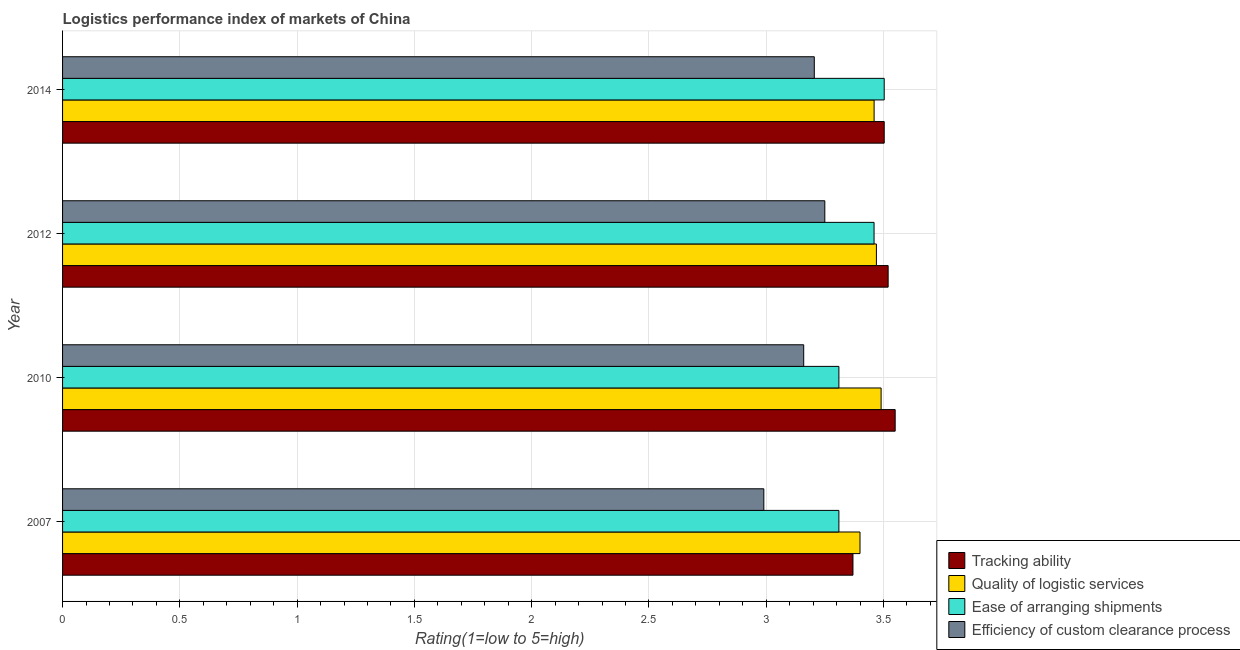How many groups of bars are there?
Your answer should be compact. 4. Are the number of bars on each tick of the Y-axis equal?
Your answer should be compact. Yes. How many bars are there on the 2nd tick from the top?
Ensure brevity in your answer.  4. How many bars are there on the 4th tick from the bottom?
Your answer should be very brief. 4. What is the label of the 1st group of bars from the top?
Offer a very short reply. 2014. What is the lpi rating of quality of logistic services in 2010?
Make the answer very short. 3.49. Across all years, what is the maximum lpi rating of ease of arranging shipments?
Ensure brevity in your answer.  3.5. Across all years, what is the minimum lpi rating of ease of arranging shipments?
Your response must be concise. 3.31. In which year was the lpi rating of efficiency of custom clearance process maximum?
Offer a terse response. 2012. In which year was the lpi rating of tracking ability minimum?
Your response must be concise. 2007. What is the total lpi rating of tracking ability in the graph?
Your answer should be very brief. 13.94. What is the difference between the lpi rating of efficiency of custom clearance process in 2007 and that in 2012?
Ensure brevity in your answer.  -0.26. What is the difference between the lpi rating of tracking ability in 2012 and the lpi rating of ease of arranging shipments in 2014?
Give a very brief answer. 0.02. What is the average lpi rating of efficiency of custom clearance process per year?
Offer a very short reply. 3.15. In the year 2007, what is the difference between the lpi rating of quality of logistic services and lpi rating of tracking ability?
Offer a very short reply. 0.03. In how many years, is the lpi rating of tracking ability greater than 2.4 ?
Provide a succinct answer. 4. Is the difference between the lpi rating of quality of logistic services in 2010 and 2014 greater than the difference between the lpi rating of efficiency of custom clearance process in 2010 and 2014?
Keep it short and to the point. Yes. What is the difference between the highest and the second highest lpi rating of efficiency of custom clearance process?
Your response must be concise. 0.04. What is the difference between the highest and the lowest lpi rating of efficiency of custom clearance process?
Ensure brevity in your answer.  0.26. In how many years, is the lpi rating of quality of logistic services greater than the average lpi rating of quality of logistic services taken over all years?
Provide a short and direct response. 3. Is the sum of the lpi rating of ease of arranging shipments in 2010 and 2014 greater than the maximum lpi rating of quality of logistic services across all years?
Offer a terse response. Yes. What does the 3rd bar from the top in 2010 represents?
Provide a short and direct response. Quality of logistic services. What does the 4th bar from the bottom in 2012 represents?
Provide a succinct answer. Efficiency of custom clearance process. Is it the case that in every year, the sum of the lpi rating of tracking ability and lpi rating of quality of logistic services is greater than the lpi rating of ease of arranging shipments?
Your answer should be very brief. Yes. How many bars are there?
Ensure brevity in your answer.  16. Are the values on the major ticks of X-axis written in scientific E-notation?
Provide a succinct answer. No. How are the legend labels stacked?
Offer a terse response. Vertical. What is the title of the graph?
Your answer should be compact. Logistics performance index of markets of China. What is the label or title of the X-axis?
Your answer should be compact. Rating(1=low to 5=high). What is the Rating(1=low to 5=high) in Tracking ability in 2007?
Offer a very short reply. 3.37. What is the Rating(1=low to 5=high) in Quality of logistic services in 2007?
Provide a succinct answer. 3.4. What is the Rating(1=low to 5=high) in Ease of arranging shipments in 2007?
Provide a short and direct response. 3.31. What is the Rating(1=low to 5=high) of Efficiency of custom clearance process in 2007?
Offer a very short reply. 2.99. What is the Rating(1=low to 5=high) in Tracking ability in 2010?
Give a very brief answer. 3.55. What is the Rating(1=low to 5=high) in Quality of logistic services in 2010?
Your answer should be very brief. 3.49. What is the Rating(1=low to 5=high) in Ease of arranging shipments in 2010?
Give a very brief answer. 3.31. What is the Rating(1=low to 5=high) in Efficiency of custom clearance process in 2010?
Keep it short and to the point. 3.16. What is the Rating(1=low to 5=high) in Tracking ability in 2012?
Make the answer very short. 3.52. What is the Rating(1=low to 5=high) of Quality of logistic services in 2012?
Your answer should be compact. 3.47. What is the Rating(1=low to 5=high) of Ease of arranging shipments in 2012?
Provide a short and direct response. 3.46. What is the Rating(1=low to 5=high) in Efficiency of custom clearance process in 2012?
Give a very brief answer. 3.25. What is the Rating(1=low to 5=high) of Tracking ability in 2014?
Provide a short and direct response. 3.5. What is the Rating(1=low to 5=high) in Quality of logistic services in 2014?
Keep it short and to the point. 3.46. What is the Rating(1=low to 5=high) of Ease of arranging shipments in 2014?
Make the answer very short. 3.5. What is the Rating(1=low to 5=high) in Efficiency of custom clearance process in 2014?
Provide a short and direct response. 3.21. Across all years, what is the maximum Rating(1=low to 5=high) in Tracking ability?
Make the answer very short. 3.55. Across all years, what is the maximum Rating(1=low to 5=high) in Quality of logistic services?
Offer a very short reply. 3.49. Across all years, what is the maximum Rating(1=low to 5=high) of Ease of arranging shipments?
Your answer should be very brief. 3.5. Across all years, what is the minimum Rating(1=low to 5=high) in Tracking ability?
Your answer should be very brief. 3.37. Across all years, what is the minimum Rating(1=low to 5=high) in Quality of logistic services?
Ensure brevity in your answer.  3.4. Across all years, what is the minimum Rating(1=low to 5=high) in Ease of arranging shipments?
Offer a very short reply. 3.31. Across all years, what is the minimum Rating(1=low to 5=high) of Efficiency of custom clearance process?
Make the answer very short. 2.99. What is the total Rating(1=low to 5=high) of Tracking ability in the graph?
Make the answer very short. 13.94. What is the total Rating(1=low to 5=high) in Quality of logistic services in the graph?
Make the answer very short. 13.82. What is the total Rating(1=low to 5=high) of Ease of arranging shipments in the graph?
Make the answer very short. 13.58. What is the total Rating(1=low to 5=high) of Efficiency of custom clearance process in the graph?
Give a very brief answer. 12.61. What is the difference between the Rating(1=low to 5=high) in Tracking ability in 2007 and that in 2010?
Offer a terse response. -0.18. What is the difference between the Rating(1=low to 5=high) of Quality of logistic services in 2007 and that in 2010?
Provide a short and direct response. -0.09. What is the difference between the Rating(1=low to 5=high) of Efficiency of custom clearance process in 2007 and that in 2010?
Keep it short and to the point. -0.17. What is the difference between the Rating(1=low to 5=high) in Tracking ability in 2007 and that in 2012?
Make the answer very short. -0.15. What is the difference between the Rating(1=low to 5=high) in Quality of logistic services in 2007 and that in 2012?
Your answer should be compact. -0.07. What is the difference between the Rating(1=low to 5=high) in Efficiency of custom clearance process in 2007 and that in 2012?
Provide a succinct answer. -0.26. What is the difference between the Rating(1=low to 5=high) in Tracking ability in 2007 and that in 2014?
Keep it short and to the point. -0.13. What is the difference between the Rating(1=low to 5=high) in Quality of logistic services in 2007 and that in 2014?
Keep it short and to the point. -0.06. What is the difference between the Rating(1=low to 5=high) in Ease of arranging shipments in 2007 and that in 2014?
Your answer should be compact. -0.19. What is the difference between the Rating(1=low to 5=high) of Efficiency of custom clearance process in 2007 and that in 2014?
Your response must be concise. -0.22. What is the difference between the Rating(1=low to 5=high) of Quality of logistic services in 2010 and that in 2012?
Provide a succinct answer. 0.02. What is the difference between the Rating(1=low to 5=high) of Efficiency of custom clearance process in 2010 and that in 2012?
Ensure brevity in your answer.  -0.09. What is the difference between the Rating(1=low to 5=high) of Tracking ability in 2010 and that in 2014?
Give a very brief answer. 0.05. What is the difference between the Rating(1=low to 5=high) of Quality of logistic services in 2010 and that in 2014?
Offer a terse response. 0.03. What is the difference between the Rating(1=low to 5=high) in Ease of arranging shipments in 2010 and that in 2014?
Make the answer very short. -0.19. What is the difference between the Rating(1=low to 5=high) of Efficiency of custom clearance process in 2010 and that in 2014?
Provide a short and direct response. -0.05. What is the difference between the Rating(1=low to 5=high) in Tracking ability in 2012 and that in 2014?
Make the answer very short. 0.02. What is the difference between the Rating(1=low to 5=high) of Quality of logistic services in 2012 and that in 2014?
Offer a very short reply. 0.01. What is the difference between the Rating(1=low to 5=high) of Ease of arranging shipments in 2012 and that in 2014?
Ensure brevity in your answer.  -0.04. What is the difference between the Rating(1=low to 5=high) in Efficiency of custom clearance process in 2012 and that in 2014?
Provide a short and direct response. 0.04. What is the difference between the Rating(1=low to 5=high) of Tracking ability in 2007 and the Rating(1=low to 5=high) of Quality of logistic services in 2010?
Provide a short and direct response. -0.12. What is the difference between the Rating(1=low to 5=high) of Tracking ability in 2007 and the Rating(1=low to 5=high) of Efficiency of custom clearance process in 2010?
Your answer should be very brief. 0.21. What is the difference between the Rating(1=low to 5=high) of Quality of logistic services in 2007 and the Rating(1=low to 5=high) of Ease of arranging shipments in 2010?
Keep it short and to the point. 0.09. What is the difference between the Rating(1=low to 5=high) in Quality of logistic services in 2007 and the Rating(1=low to 5=high) in Efficiency of custom clearance process in 2010?
Keep it short and to the point. 0.24. What is the difference between the Rating(1=low to 5=high) of Tracking ability in 2007 and the Rating(1=low to 5=high) of Quality of logistic services in 2012?
Offer a terse response. -0.1. What is the difference between the Rating(1=low to 5=high) of Tracking ability in 2007 and the Rating(1=low to 5=high) of Ease of arranging shipments in 2012?
Offer a very short reply. -0.09. What is the difference between the Rating(1=low to 5=high) in Tracking ability in 2007 and the Rating(1=low to 5=high) in Efficiency of custom clearance process in 2012?
Provide a short and direct response. 0.12. What is the difference between the Rating(1=low to 5=high) of Quality of logistic services in 2007 and the Rating(1=low to 5=high) of Ease of arranging shipments in 2012?
Provide a short and direct response. -0.06. What is the difference between the Rating(1=low to 5=high) in Quality of logistic services in 2007 and the Rating(1=low to 5=high) in Efficiency of custom clearance process in 2012?
Provide a short and direct response. 0.15. What is the difference between the Rating(1=low to 5=high) in Ease of arranging shipments in 2007 and the Rating(1=low to 5=high) in Efficiency of custom clearance process in 2012?
Keep it short and to the point. 0.06. What is the difference between the Rating(1=low to 5=high) in Tracking ability in 2007 and the Rating(1=low to 5=high) in Quality of logistic services in 2014?
Offer a very short reply. -0.09. What is the difference between the Rating(1=low to 5=high) of Tracking ability in 2007 and the Rating(1=low to 5=high) of Ease of arranging shipments in 2014?
Give a very brief answer. -0.13. What is the difference between the Rating(1=low to 5=high) in Tracking ability in 2007 and the Rating(1=low to 5=high) in Efficiency of custom clearance process in 2014?
Offer a very short reply. 0.16. What is the difference between the Rating(1=low to 5=high) in Quality of logistic services in 2007 and the Rating(1=low to 5=high) in Ease of arranging shipments in 2014?
Your answer should be very brief. -0.1. What is the difference between the Rating(1=low to 5=high) in Quality of logistic services in 2007 and the Rating(1=low to 5=high) in Efficiency of custom clearance process in 2014?
Provide a short and direct response. 0.19. What is the difference between the Rating(1=low to 5=high) of Ease of arranging shipments in 2007 and the Rating(1=low to 5=high) of Efficiency of custom clearance process in 2014?
Ensure brevity in your answer.  0.1. What is the difference between the Rating(1=low to 5=high) in Tracking ability in 2010 and the Rating(1=low to 5=high) in Ease of arranging shipments in 2012?
Make the answer very short. 0.09. What is the difference between the Rating(1=low to 5=high) of Tracking ability in 2010 and the Rating(1=low to 5=high) of Efficiency of custom clearance process in 2012?
Give a very brief answer. 0.3. What is the difference between the Rating(1=low to 5=high) in Quality of logistic services in 2010 and the Rating(1=low to 5=high) in Ease of arranging shipments in 2012?
Provide a succinct answer. 0.03. What is the difference between the Rating(1=low to 5=high) in Quality of logistic services in 2010 and the Rating(1=low to 5=high) in Efficiency of custom clearance process in 2012?
Keep it short and to the point. 0.24. What is the difference between the Rating(1=low to 5=high) of Ease of arranging shipments in 2010 and the Rating(1=low to 5=high) of Efficiency of custom clearance process in 2012?
Your response must be concise. 0.06. What is the difference between the Rating(1=low to 5=high) of Tracking ability in 2010 and the Rating(1=low to 5=high) of Quality of logistic services in 2014?
Your answer should be very brief. 0.09. What is the difference between the Rating(1=low to 5=high) in Tracking ability in 2010 and the Rating(1=low to 5=high) in Ease of arranging shipments in 2014?
Your response must be concise. 0.05. What is the difference between the Rating(1=low to 5=high) in Tracking ability in 2010 and the Rating(1=low to 5=high) in Efficiency of custom clearance process in 2014?
Your answer should be very brief. 0.34. What is the difference between the Rating(1=low to 5=high) of Quality of logistic services in 2010 and the Rating(1=low to 5=high) of Ease of arranging shipments in 2014?
Give a very brief answer. -0.01. What is the difference between the Rating(1=low to 5=high) in Quality of logistic services in 2010 and the Rating(1=low to 5=high) in Efficiency of custom clearance process in 2014?
Provide a short and direct response. 0.28. What is the difference between the Rating(1=low to 5=high) of Ease of arranging shipments in 2010 and the Rating(1=low to 5=high) of Efficiency of custom clearance process in 2014?
Your answer should be very brief. 0.1. What is the difference between the Rating(1=low to 5=high) in Tracking ability in 2012 and the Rating(1=low to 5=high) in Quality of logistic services in 2014?
Your answer should be very brief. 0.06. What is the difference between the Rating(1=low to 5=high) in Tracking ability in 2012 and the Rating(1=low to 5=high) in Ease of arranging shipments in 2014?
Your answer should be compact. 0.02. What is the difference between the Rating(1=low to 5=high) of Tracking ability in 2012 and the Rating(1=low to 5=high) of Efficiency of custom clearance process in 2014?
Give a very brief answer. 0.31. What is the difference between the Rating(1=low to 5=high) of Quality of logistic services in 2012 and the Rating(1=low to 5=high) of Ease of arranging shipments in 2014?
Offer a very short reply. -0.03. What is the difference between the Rating(1=low to 5=high) of Quality of logistic services in 2012 and the Rating(1=low to 5=high) of Efficiency of custom clearance process in 2014?
Keep it short and to the point. 0.26. What is the difference between the Rating(1=low to 5=high) of Ease of arranging shipments in 2012 and the Rating(1=low to 5=high) of Efficiency of custom clearance process in 2014?
Your response must be concise. 0.25. What is the average Rating(1=low to 5=high) in Tracking ability per year?
Provide a succinct answer. 3.49. What is the average Rating(1=low to 5=high) in Quality of logistic services per year?
Your answer should be very brief. 3.46. What is the average Rating(1=low to 5=high) of Ease of arranging shipments per year?
Your answer should be compact. 3.4. What is the average Rating(1=low to 5=high) in Efficiency of custom clearance process per year?
Keep it short and to the point. 3.15. In the year 2007, what is the difference between the Rating(1=low to 5=high) in Tracking ability and Rating(1=low to 5=high) in Quality of logistic services?
Give a very brief answer. -0.03. In the year 2007, what is the difference between the Rating(1=low to 5=high) of Tracking ability and Rating(1=low to 5=high) of Ease of arranging shipments?
Give a very brief answer. 0.06. In the year 2007, what is the difference between the Rating(1=low to 5=high) in Tracking ability and Rating(1=low to 5=high) in Efficiency of custom clearance process?
Offer a terse response. 0.38. In the year 2007, what is the difference between the Rating(1=low to 5=high) of Quality of logistic services and Rating(1=low to 5=high) of Ease of arranging shipments?
Your answer should be compact. 0.09. In the year 2007, what is the difference between the Rating(1=low to 5=high) of Quality of logistic services and Rating(1=low to 5=high) of Efficiency of custom clearance process?
Your answer should be compact. 0.41. In the year 2007, what is the difference between the Rating(1=low to 5=high) in Ease of arranging shipments and Rating(1=low to 5=high) in Efficiency of custom clearance process?
Offer a terse response. 0.32. In the year 2010, what is the difference between the Rating(1=low to 5=high) of Tracking ability and Rating(1=low to 5=high) of Quality of logistic services?
Your response must be concise. 0.06. In the year 2010, what is the difference between the Rating(1=low to 5=high) of Tracking ability and Rating(1=low to 5=high) of Ease of arranging shipments?
Your answer should be very brief. 0.24. In the year 2010, what is the difference between the Rating(1=low to 5=high) of Tracking ability and Rating(1=low to 5=high) of Efficiency of custom clearance process?
Your response must be concise. 0.39. In the year 2010, what is the difference between the Rating(1=low to 5=high) of Quality of logistic services and Rating(1=low to 5=high) of Ease of arranging shipments?
Give a very brief answer. 0.18. In the year 2010, what is the difference between the Rating(1=low to 5=high) of Quality of logistic services and Rating(1=low to 5=high) of Efficiency of custom clearance process?
Offer a very short reply. 0.33. In the year 2010, what is the difference between the Rating(1=low to 5=high) of Ease of arranging shipments and Rating(1=low to 5=high) of Efficiency of custom clearance process?
Provide a short and direct response. 0.15. In the year 2012, what is the difference between the Rating(1=low to 5=high) in Tracking ability and Rating(1=low to 5=high) in Ease of arranging shipments?
Keep it short and to the point. 0.06. In the year 2012, what is the difference between the Rating(1=low to 5=high) of Tracking ability and Rating(1=low to 5=high) of Efficiency of custom clearance process?
Offer a very short reply. 0.27. In the year 2012, what is the difference between the Rating(1=low to 5=high) of Quality of logistic services and Rating(1=low to 5=high) of Ease of arranging shipments?
Provide a succinct answer. 0.01. In the year 2012, what is the difference between the Rating(1=low to 5=high) of Quality of logistic services and Rating(1=low to 5=high) of Efficiency of custom clearance process?
Keep it short and to the point. 0.22. In the year 2012, what is the difference between the Rating(1=low to 5=high) of Ease of arranging shipments and Rating(1=low to 5=high) of Efficiency of custom clearance process?
Offer a very short reply. 0.21. In the year 2014, what is the difference between the Rating(1=low to 5=high) of Tracking ability and Rating(1=low to 5=high) of Quality of logistic services?
Give a very brief answer. 0.04. In the year 2014, what is the difference between the Rating(1=low to 5=high) of Tracking ability and Rating(1=low to 5=high) of Ease of arranging shipments?
Offer a terse response. 0. In the year 2014, what is the difference between the Rating(1=low to 5=high) of Tracking ability and Rating(1=low to 5=high) of Efficiency of custom clearance process?
Offer a very short reply. 0.3. In the year 2014, what is the difference between the Rating(1=low to 5=high) in Quality of logistic services and Rating(1=low to 5=high) in Ease of arranging shipments?
Offer a very short reply. -0.04. In the year 2014, what is the difference between the Rating(1=low to 5=high) of Quality of logistic services and Rating(1=low to 5=high) of Efficiency of custom clearance process?
Give a very brief answer. 0.26. In the year 2014, what is the difference between the Rating(1=low to 5=high) in Ease of arranging shipments and Rating(1=low to 5=high) in Efficiency of custom clearance process?
Ensure brevity in your answer.  0.3. What is the ratio of the Rating(1=low to 5=high) in Tracking ability in 2007 to that in 2010?
Provide a short and direct response. 0.95. What is the ratio of the Rating(1=low to 5=high) of Quality of logistic services in 2007 to that in 2010?
Provide a short and direct response. 0.97. What is the ratio of the Rating(1=low to 5=high) of Ease of arranging shipments in 2007 to that in 2010?
Keep it short and to the point. 1. What is the ratio of the Rating(1=low to 5=high) of Efficiency of custom clearance process in 2007 to that in 2010?
Offer a terse response. 0.95. What is the ratio of the Rating(1=low to 5=high) in Tracking ability in 2007 to that in 2012?
Provide a succinct answer. 0.96. What is the ratio of the Rating(1=low to 5=high) of Quality of logistic services in 2007 to that in 2012?
Make the answer very short. 0.98. What is the ratio of the Rating(1=low to 5=high) of Ease of arranging shipments in 2007 to that in 2012?
Your answer should be compact. 0.96. What is the ratio of the Rating(1=low to 5=high) of Efficiency of custom clearance process in 2007 to that in 2012?
Offer a terse response. 0.92. What is the ratio of the Rating(1=low to 5=high) in Quality of logistic services in 2007 to that in 2014?
Give a very brief answer. 0.98. What is the ratio of the Rating(1=low to 5=high) in Ease of arranging shipments in 2007 to that in 2014?
Make the answer very short. 0.94. What is the ratio of the Rating(1=low to 5=high) of Efficiency of custom clearance process in 2007 to that in 2014?
Provide a succinct answer. 0.93. What is the ratio of the Rating(1=low to 5=high) in Tracking ability in 2010 to that in 2012?
Your answer should be compact. 1.01. What is the ratio of the Rating(1=low to 5=high) of Quality of logistic services in 2010 to that in 2012?
Make the answer very short. 1.01. What is the ratio of the Rating(1=low to 5=high) in Ease of arranging shipments in 2010 to that in 2012?
Give a very brief answer. 0.96. What is the ratio of the Rating(1=low to 5=high) of Efficiency of custom clearance process in 2010 to that in 2012?
Give a very brief answer. 0.97. What is the ratio of the Rating(1=low to 5=high) in Tracking ability in 2010 to that in 2014?
Offer a very short reply. 1.01. What is the ratio of the Rating(1=low to 5=high) of Quality of logistic services in 2010 to that in 2014?
Offer a very short reply. 1.01. What is the ratio of the Rating(1=low to 5=high) of Ease of arranging shipments in 2010 to that in 2014?
Offer a terse response. 0.94. What is the ratio of the Rating(1=low to 5=high) in Efficiency of custom clearance process in 2010 to that in 2014?
Offer a terse response. 0.99. What is the ratio of the Rating(1=low to 5=high) in Tracking ability in 2012 to that in 2014?
Offer a terse response. 1. What is the ratio of the Rating(1=low to 5=high) in Ease of arranging shipments in 2012 to that in 2014?
Make the answer very short. 0.99. What is the difference between the highest and the second highest Rating(1=low to 5=high) of Tracking ability?
Ensure brevity in your answer.  0.03. What is the difference between the highest and the second highest Rating(1=low to 5=high) of Ease of arranging shipments?
Ensure brevity in your answer.  0.04. What is the difference between the highest and the second highest Rating(1=low to 5=high) of Efficiency of custom clearance process?
Your answer should be very brief. 0.04. What is the difference between the highest and the lowest Rating(1=low to 5=high) of Tracking ability?
Your answer should be compact. 0.18. What is the difference between the highest and the lowest Rating(1=low to 5=high) in Quality of logistic services?
Keep it short and to the point. 0.09. What is the difference between the highest and the lowest Rating(1=low to 5=high) in Ease of arranging shipments?
Provide a succinct answer. 0.19. What is the difference between the highest and the lowest Rating(1=low to 5=high) in Efficiency of custom clearance process?
Provide a short and direct response. 0.26. 